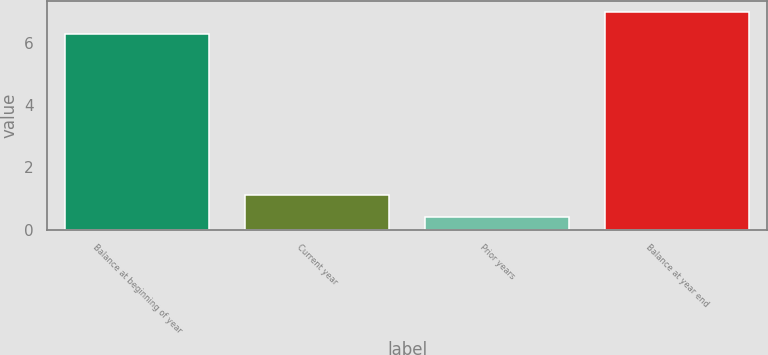Convert chart. <chart><loc_0><loc_0><loc_500><loc_500><bar_chart><fcel>Balance at beginning of year<fcel>Current year<fcel>Prior years<fcel>Balance at year end<nl><fcel>6.3<fcel>1.1<fcel>0.4<fcel>7<nl></chart> 